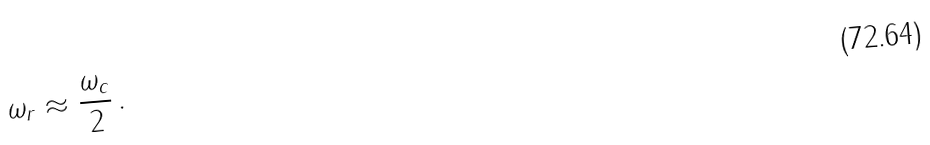<formula> <loc_0><loc_0><loc_500><loc_500>\omega _ { r } \approx \frac { \omega _ { c } } { 2 } \, .</formula> 